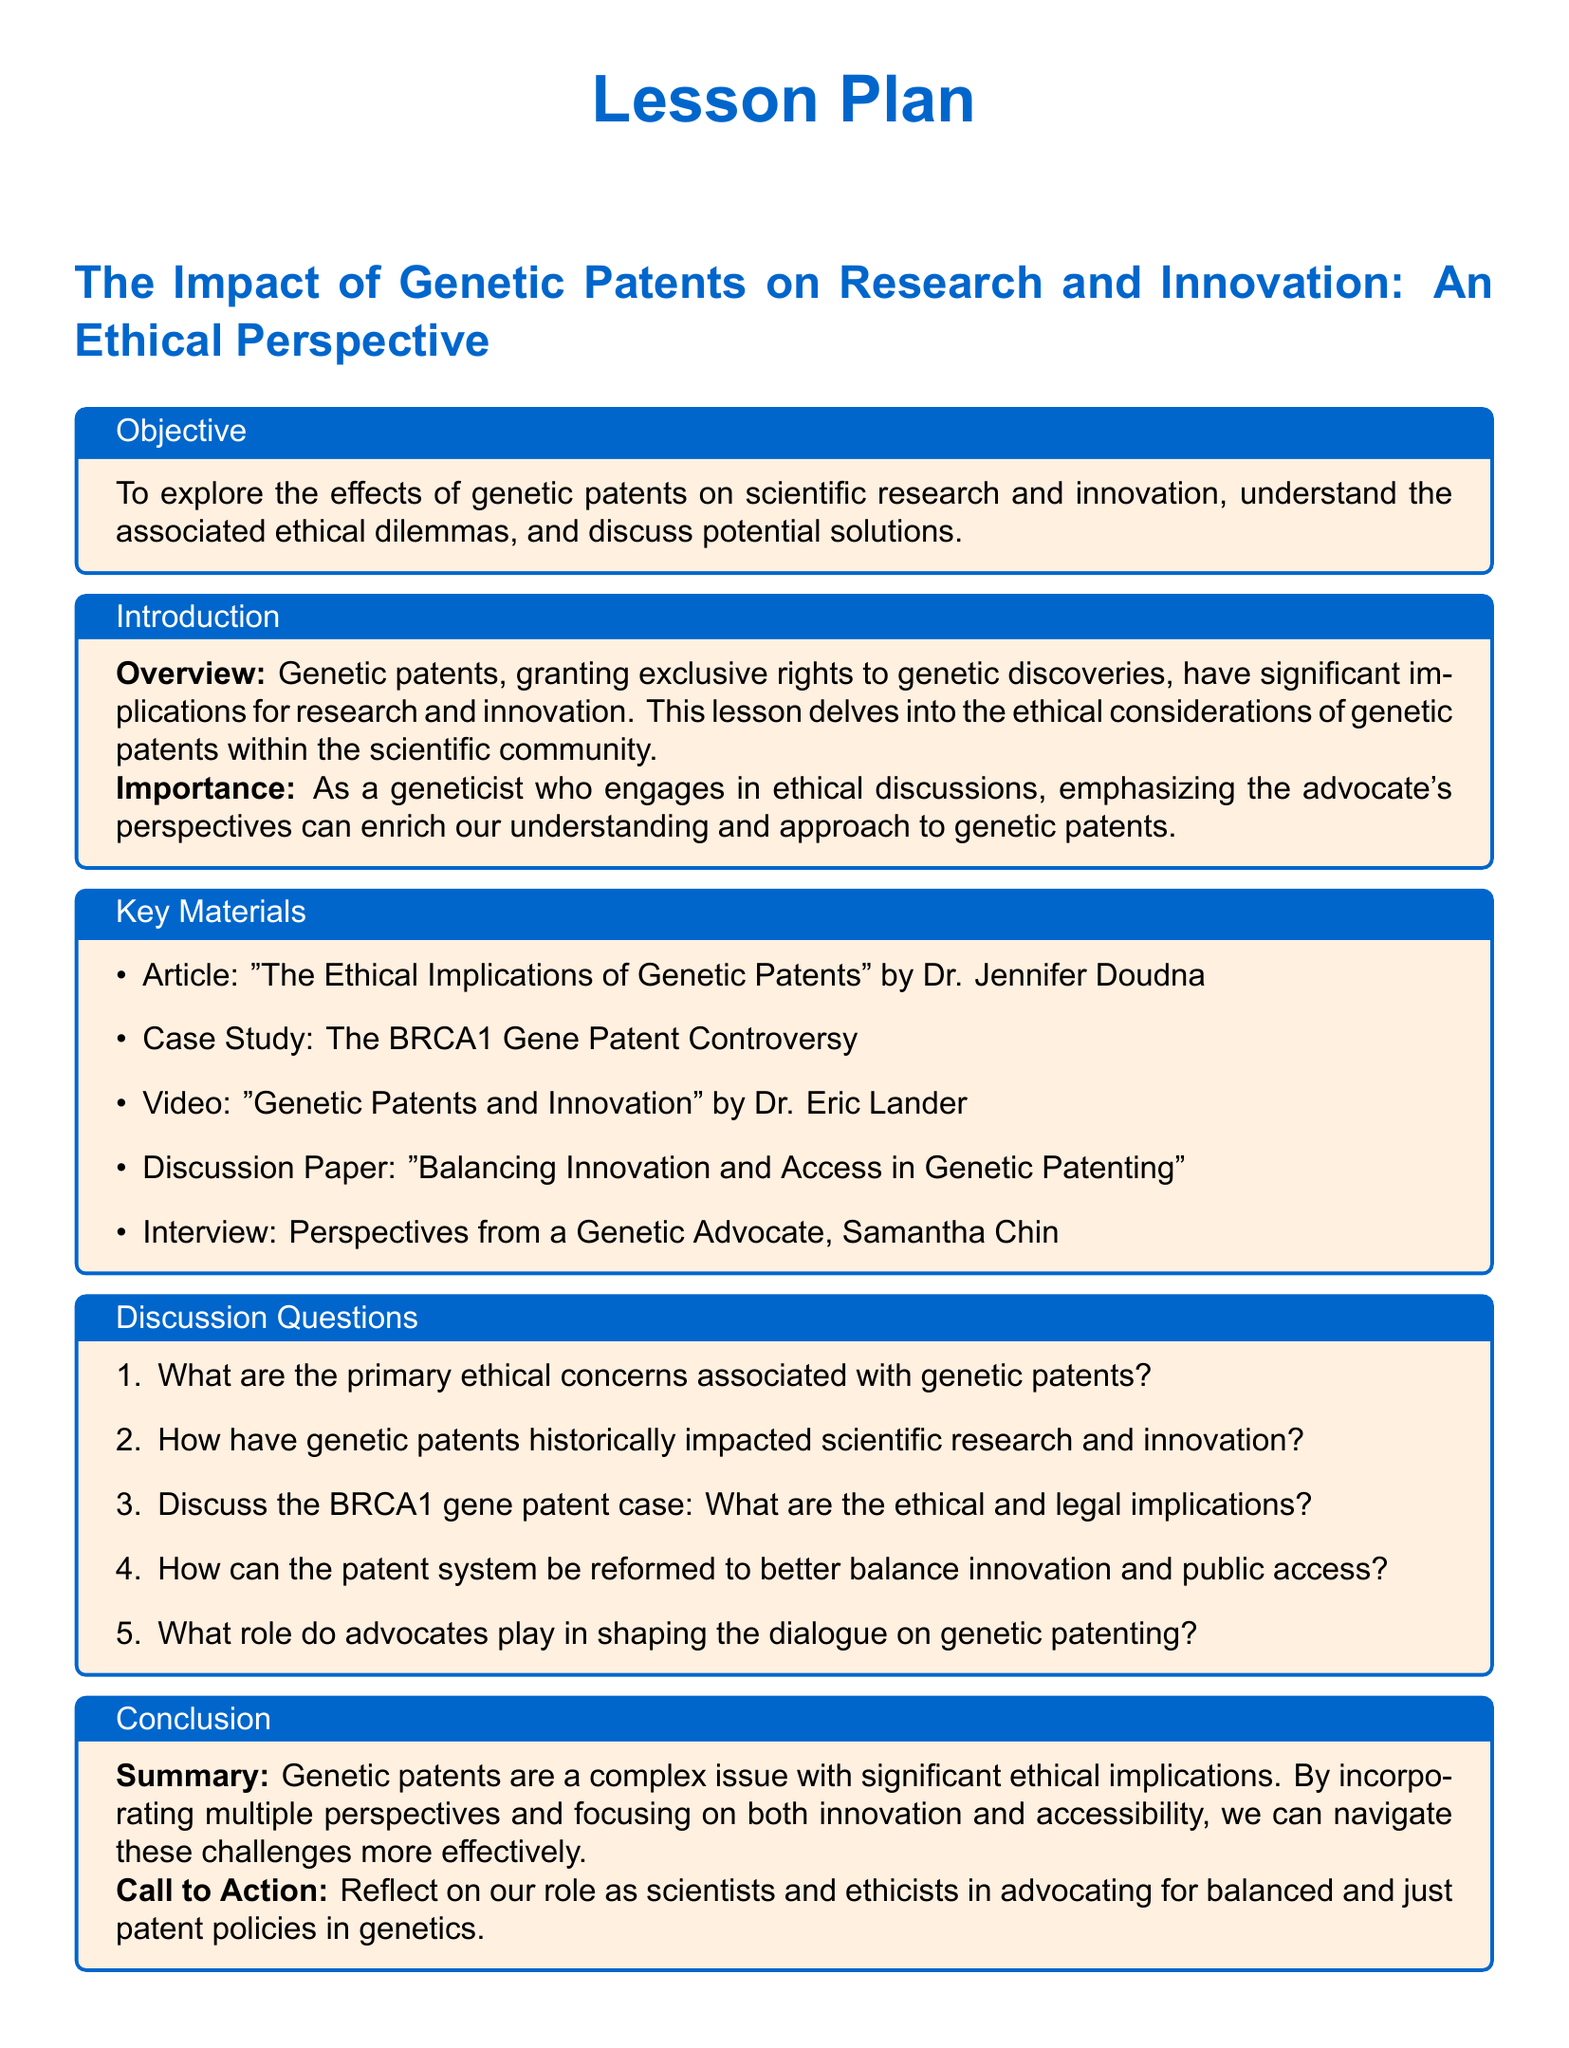What is the title of the lesson plan? The title is clearly mentioned in the section header of the document.
Answer: The Impact of Genetic Patents on Research and Innovation: An Ethical Perspective Who authored the article mentioned in the key materials? The document specifies the author of the article in the key materials section.
Answer: Dr. Jennifer Doudna What historical case is discussed in the lesson plan? The case is outlined as a specific example to illustrate the issues around genetic patents.
Answer: The BRCA1 Gene Patent Controversy How many discussion questions are included in the document? The number of items in the list of discussion questions is provided in the section.
Answer: Five What is the main objective of the lesson plan? The objective is stated explicitly in the objective box of the document.
Answer: To explore the effects of genetic patents on scientific research and innovation, understand the associated ethical dilemmas, and discuss potential solutions What is emphasized as important in the introduction? The introduction highlights a specific aspect related to the significance of discussing ethical considerations.
Answer: Incorporating the advocate's perspectives 